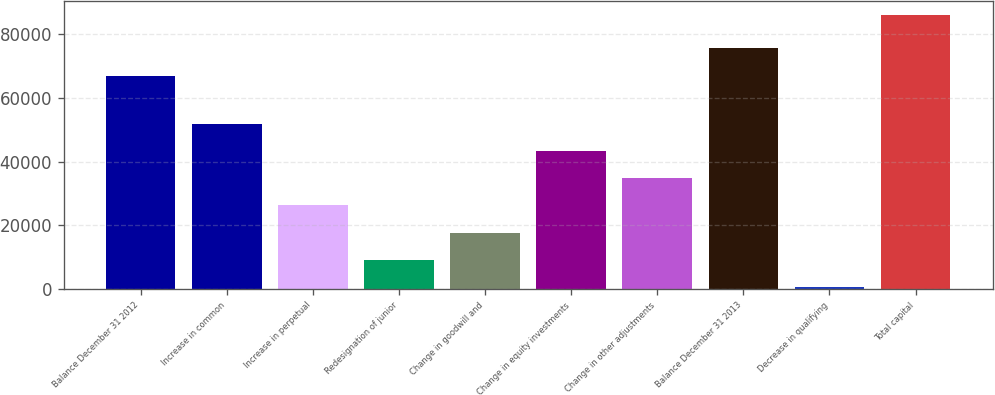Convert chart. <chart><loc_0><loc_0><loc_500><loc_500><bar_chart><fcel>Balance December 31 2012<fcel>Increase in common<fcel>Increase in perpetual<fcel>Redesignation of junior<fcel>Change in goodwill and<fcel>Change in equity investments<fcel>Change in other adjustments<fcel>Balance December 31 2013<fcel>Decrease in qualifying<fcel>Total capital<nl><fcel>66977<fcel>51889.4<fcel>26229.2<fcel>9122.4<fcel>17675.8<fcel>43336<fcel>34782.6<fcel>75530.4<fcel>569<fcel>86103<nl></chart> 